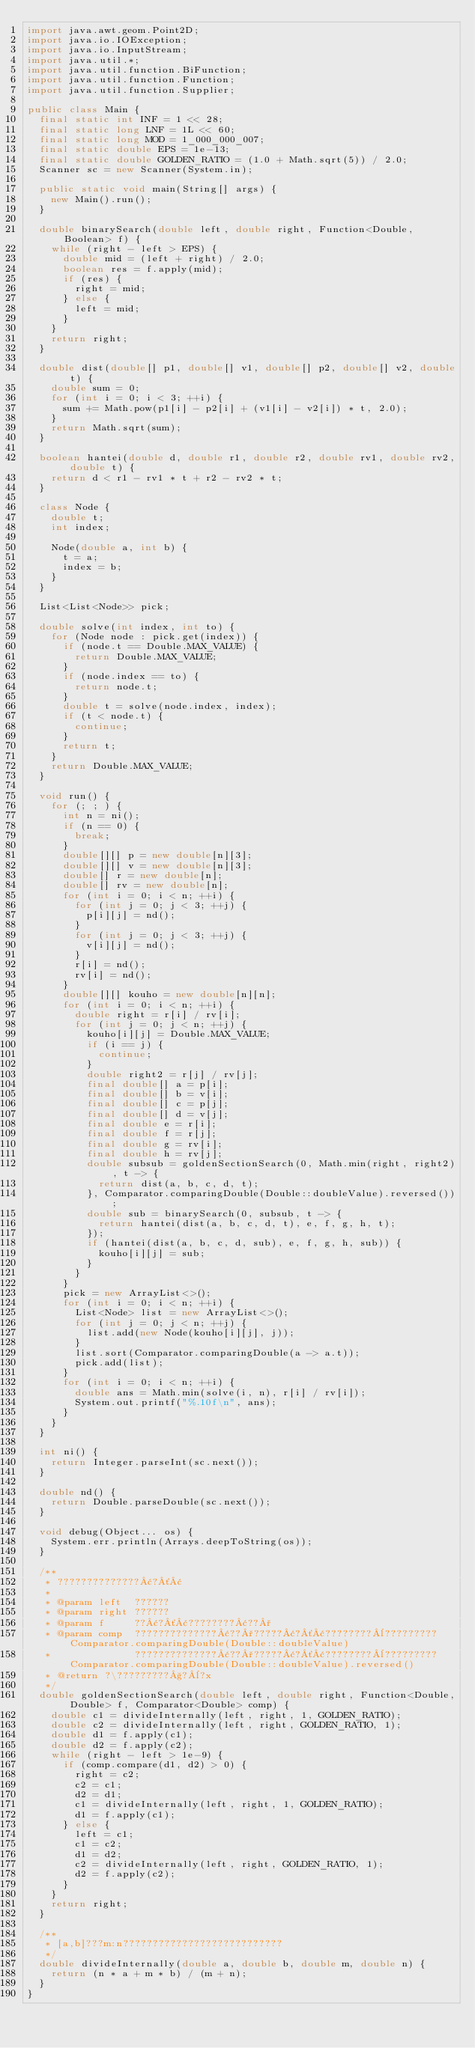<code> <loc_0><loc_0><loc_500><loc_500><_Java_>import java.awt.geom.Point2D;
import java.io.IOException;
import java.io.InputStream;
import java.util.*;
import java.util.function.BiFunction;
import java.util.function.Function;
import java.util.function.Supplier;

public class Main {
  final static int INF = 1 << 28;
  final static long LNF = 1L << 60;
  final static long MOD = 1_000_000_007;
  final static double EPS = 1e-13;
  final static double GOLDEN_RATIO = (1.0 + Math.sqrt(5)) / 2.0;
  Scanner sc = new Scanner(System.in);

  public static void main(String[] args) {
    new Main().run();
  }

  double binarySearch(double left, double right, Function<Double, Boolean> f) {
    while (right - left > EPS) {
      double mid = (left + right) / 2.0;
      boolean res = f.apply(mid);
      if (res) {
        right = mid;
      } else {
        left = mid;
      }
    }
    return right;
  }

  double dist(double[] p1, double[] v1, double[] p2, double[] v2, double t) {
    double sum = 0;
    for (int i = 0; i < 3; ++i) {
      sum += Math.pow(p1[i] - p2[i] + (v1[i] - v2[i]) * t, 2.0);
    }
    return Math.sqrt(sum);
  }

  boolean hantei(double d, double r1, double r2, double rv1, double rv2, double t) {
    return d < r1 - rv1 * t + r2 - rv2 * t;
  }

  class Node {
    double t;
    int index;

    Node(double a, int b) {
      t = a;
      index = b;
    }
  }

  List<List<Node>> pick;

  double solve(int index, int to) {
    for (Node node : pick.get(index)) {
      if (node.t == Double.MAX_VALUE) {
        return Double.MAX_VALUE;
      }
      if (node.index == to) {
        return node.t;
      }
      double t = solve(node.index, index);
      if (t < node.t) {
        continue;
      }
      return t;
    }
    return Double.MAX_VALUE;
  }

  void run() {
    for (; ; ) {
      int n = ni();
      if (n == 0) {
        break;
      }
      double[][] p = new double[n][3];
      double[][] v = new double[n][3];
      double[] r = new double[n];
      double[] rv = new double[n];
      for (int i = 0; i < n; ++i) {
        for (int j = 0; j < 3; ++j) {
          p[i][j] = nd();
        }
        for (int j = 0; j < 3; ++j) {
          v[i][j] = nd();
        }
        r[i] = nd();
        rv[i] = nd();
      }
      double[][] kouho = new double[n][n];
      for (int i = 0; i < n; ++i) {
        double right = r[i] / rv[i];
        for (int j = 0; j < n; ++j) {
          kouho[i][j] = Double.MAX_VALUE;
          if (i == j) {
            continue;
          }
          double right2 = r[j] / rv[j];
          final double[] a = p[i];
          final double[] b = v[i];
          final double[] c = p[j];
          final double[] d = v[j];
          final double e = r[i];
          final double f = r[j];
          final double g = rv[i];
          final double h = rv[j];
          double subsub = goldenSectionSearch(0, Math.min(right, right2), t -> {
            return dist(a, b, c, d, t);
          }, Comparator.comparingDouble(Double::doubleValue).reversed());
          double sub = binarySearch(0, subsub, t -> {
            return hantei(dist(a, b, c, d, t), e, f, g, h, t);
          });
          if (hantei(dist(a, b, c, d, sub), e, f, g, h, sub)) {
            kouho[i][j] = sub;
          }
        }
      }
      pick = new ArrayList<>();
      for (int i = 0; i < n; ++i) {
        List<Node> list = new ArrayList<>();
        for (int j = 0; j < n; ++j) {
          list.add(new Node(kouho[i][j], j));
        }
        list.sort(Comparator.comparingDouble(a -> a.t));
        pick.add(list);
      }
      for (int i = 0; i < n; ++i) {
        double ans = Math.min(solve(i, n), r[i] / rv[i]);
        System.out.printf("%.10f\n", ans);
      }
    }
  }

  int ni() {
    return Integer.parseInt(sc.next());
  }

  double nd() {
    return Double.parseDouble(sc.next());
  }

  void debug(Object... os) {
    System.err.println(Arrays.deepToString(os));
  }

  /**
   * ??????????????¢?´¢
   *
   * @param left  ??????
   * @param right ??????
   * @param f     ??¢?´¢????????¢??°
   * @param comp  ??????????????¢??°?????¢?´¢????????¨?????????Comparator.comparingDouble(Double::doubleValue)
   *              ??????????????¢??°?????¢?´¢????????¨?????????Comparator.comparingDouble(Double::doubleValue).reversed()
   * @return ?\?????????§?¨?x
   */
  double goldenSectionSearch(double left, double right, Function<Double, Double> f, Comparator<Double> comp) {
    double c1 = divideInternally(left, right, 1, GOLDEN_RATIO);
    double c2 = divideInternally(left, right, GOLDEN_RATIO, 1);
    double d1 = f.apply(c1);
    double d2 = f.apply(c2);
    while (right - left > 1e-9) {
      if (comp.compare(d1, d2) > 0) {
        right = c2;
        c2 = c1;
        d2 = d1;
        c1 = divideInternally(left, right, 1, GOLDEN_RATIO);
        d1 = f.apply(c1);
      } else {
        left = c1;
        c1 = c2;
        d1 = d2;
        c2 = divideInternally(left, right, GOLDEN_RATIO, 1);
        d2 = f.apply(c2);
      }
    }
    return right;
  }

  /**
   * [a,b]???m:n???????????????????????????
   */
  double divideInternally(double a, double b, double m, double n) {
    return (n * a + m * b) / (m + n);
  }
}</code> 